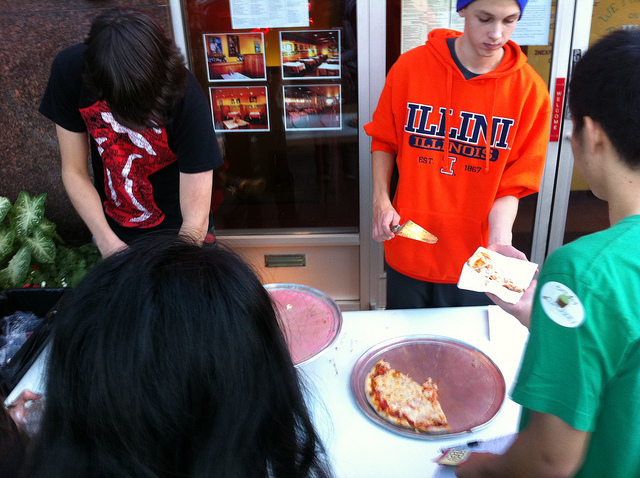Please extract the text content from this image. ILLINI ILLINOIS EST I 